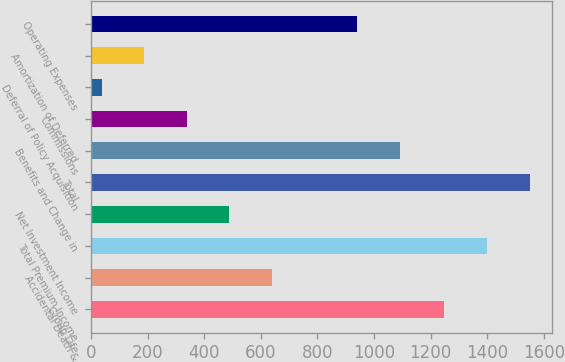Convert chart to OTSL. <chart><loc_0><loc_0><loc_500><loc_500><bar_chart><fcel>Group Life<fcel>Accidental Death &<fcel>Total Premium Income<fcel>Net Investment Income<fcel>Total<fcel>Benefits and Change in<fcel>Commissions<fcel>Deferral of Policy Acquisition<fcel>Amortization of Deferred<fcel>Operating Expenses<nl><fcel>1248.1<fcel>639.02<fcel>1399.7<fcel>488.69<fcel>1550.03<fcel>1090.01<fcel>338.36<fcel>37.7<fcel>188.03<fcel>939.68<nl></chart> 